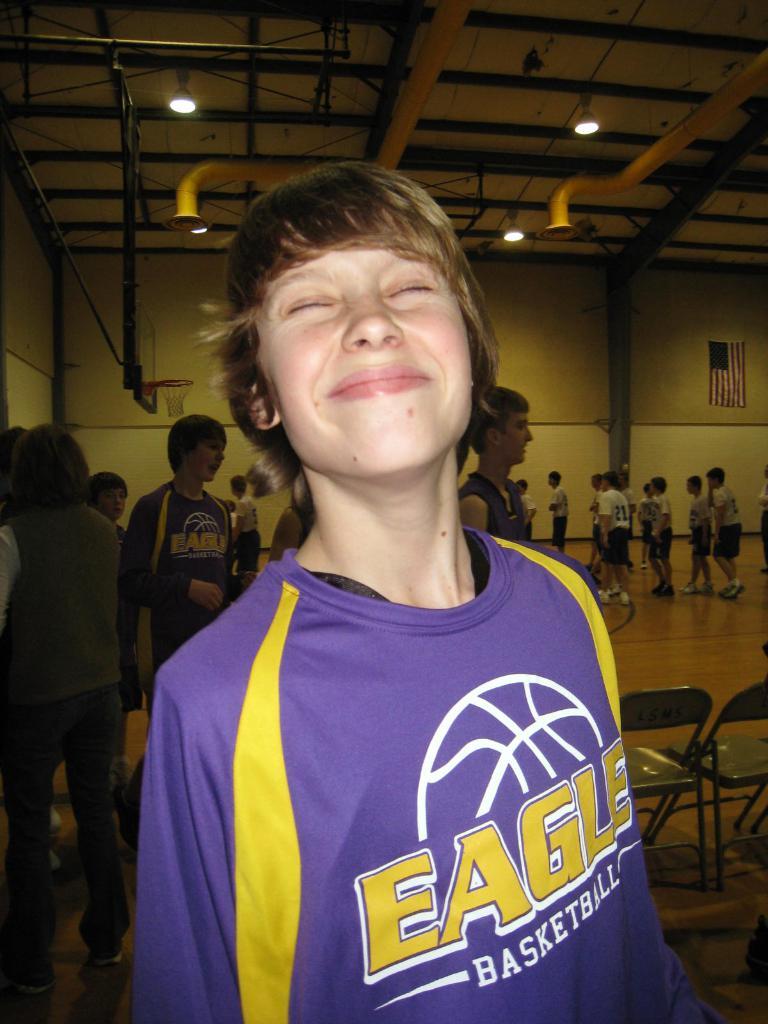What is the name of the sport printed on this shirt?
Offer a very short reply. Basketball. What team does the boy support?
Keep it short and to the point. Eagles. 